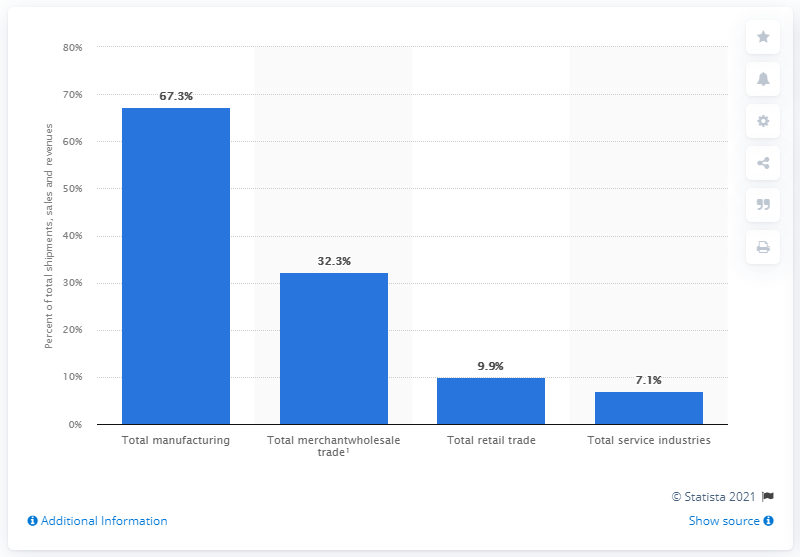Specify some key components in this picture. In 2018, e-commerce accounted for approximately 67.3% of total manufacturing shipments. In 2018, online sales accounted for approximately 9.9% of total retail trade. 